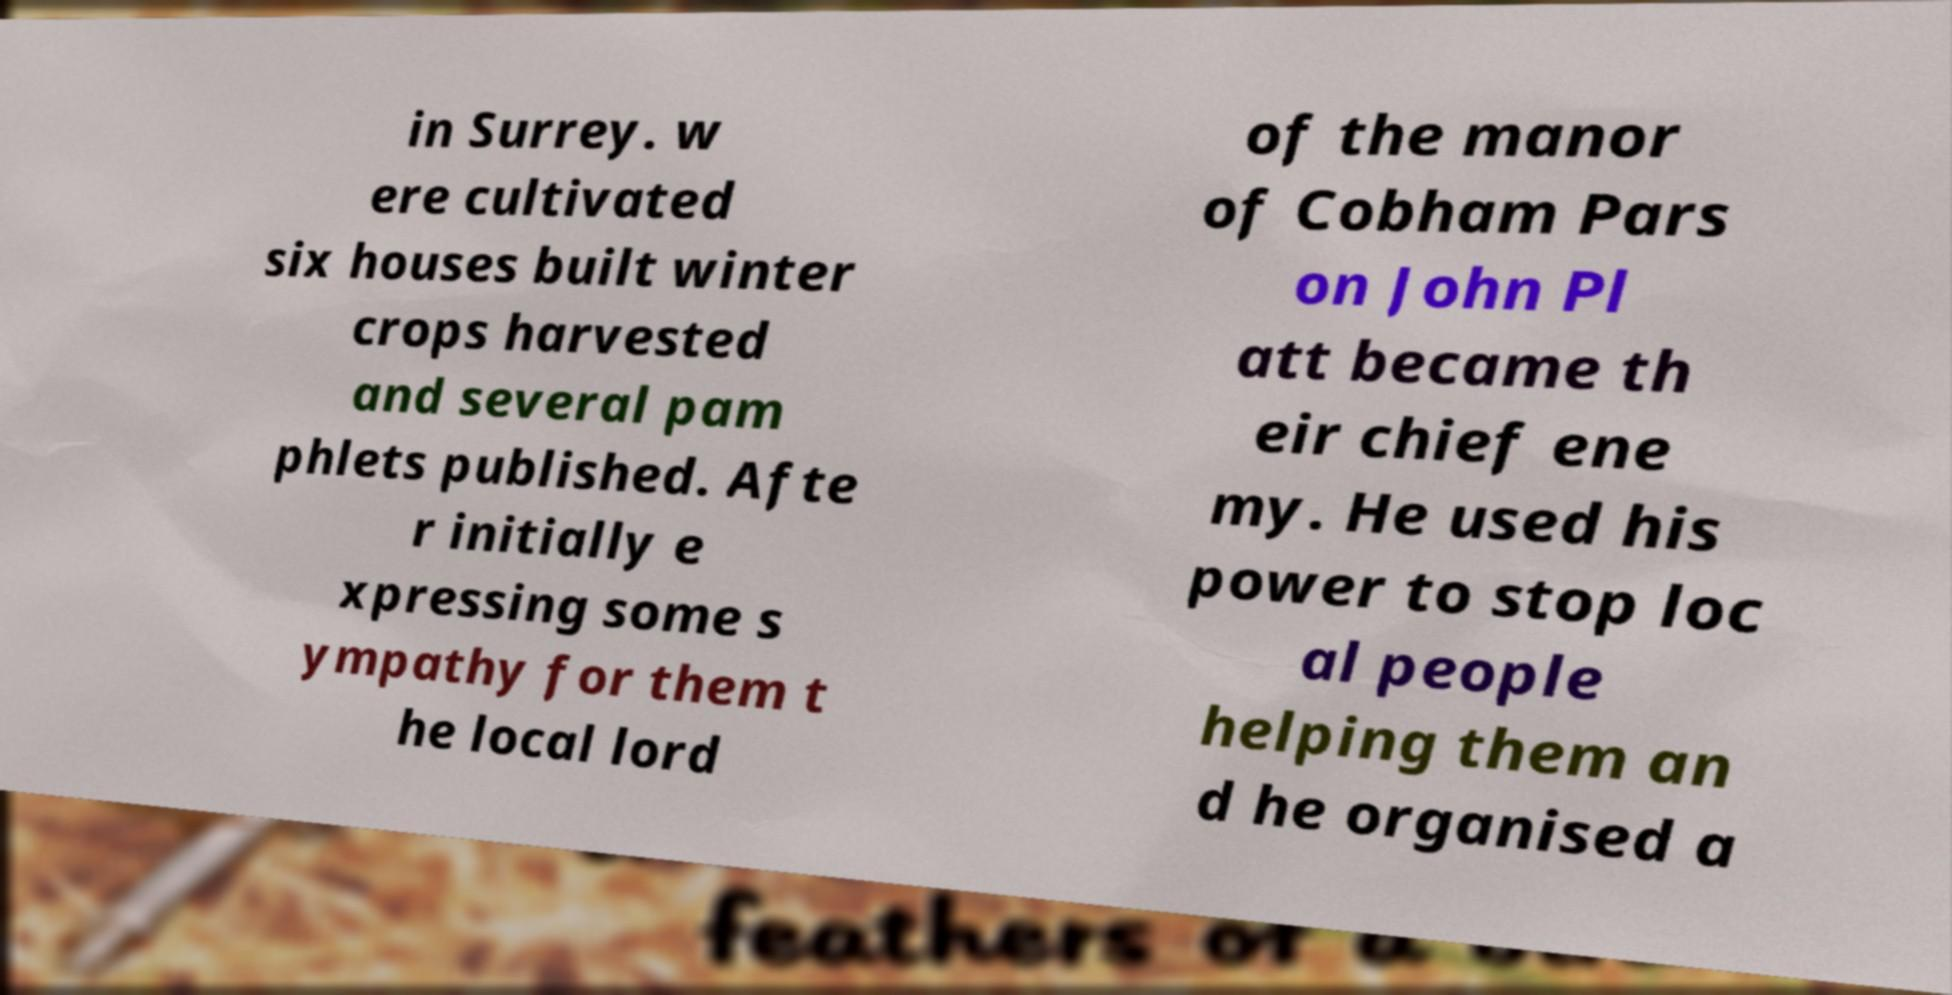Could you assist in decoding the text presented in this image and type it out clearly? in Surrey. w ere cultivated six houses built winter crops harvested and several pam phlets published. Afte r initially e xpressing some s ympathy for them t he local lord of the manor of Cobham Pars on John Pl att became th eir chief ene my. He used his power to stop loc al people helping them an d he organised a 